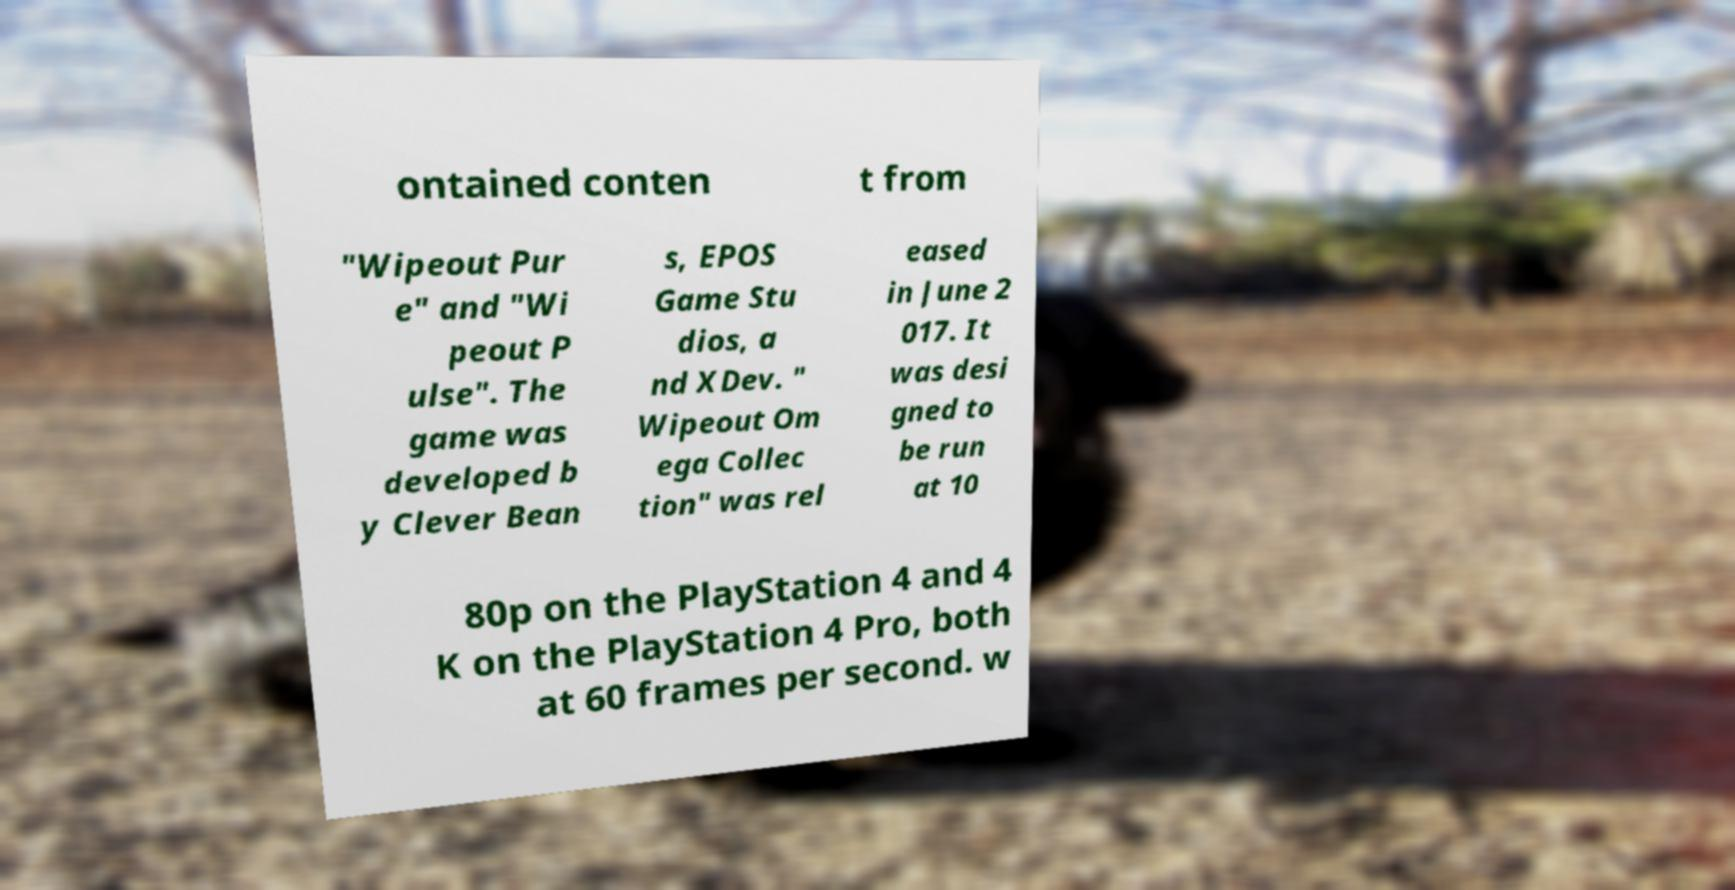Please identify and transcribe the text found in this image. ontained conten t from "Wipeout Pur e" and "Wi peout P ulse". The game was developed b y Clever Bean s, EPOS Game Stu dios, a nd XDev. " Wipeout Om ega Collec tion" was rel eased in June 2 017. It was desi gned to be run at 10 80p on the PlayStation 4 and 4 K on the PlayStation 4 Pro, both at 60 frames per second. w 